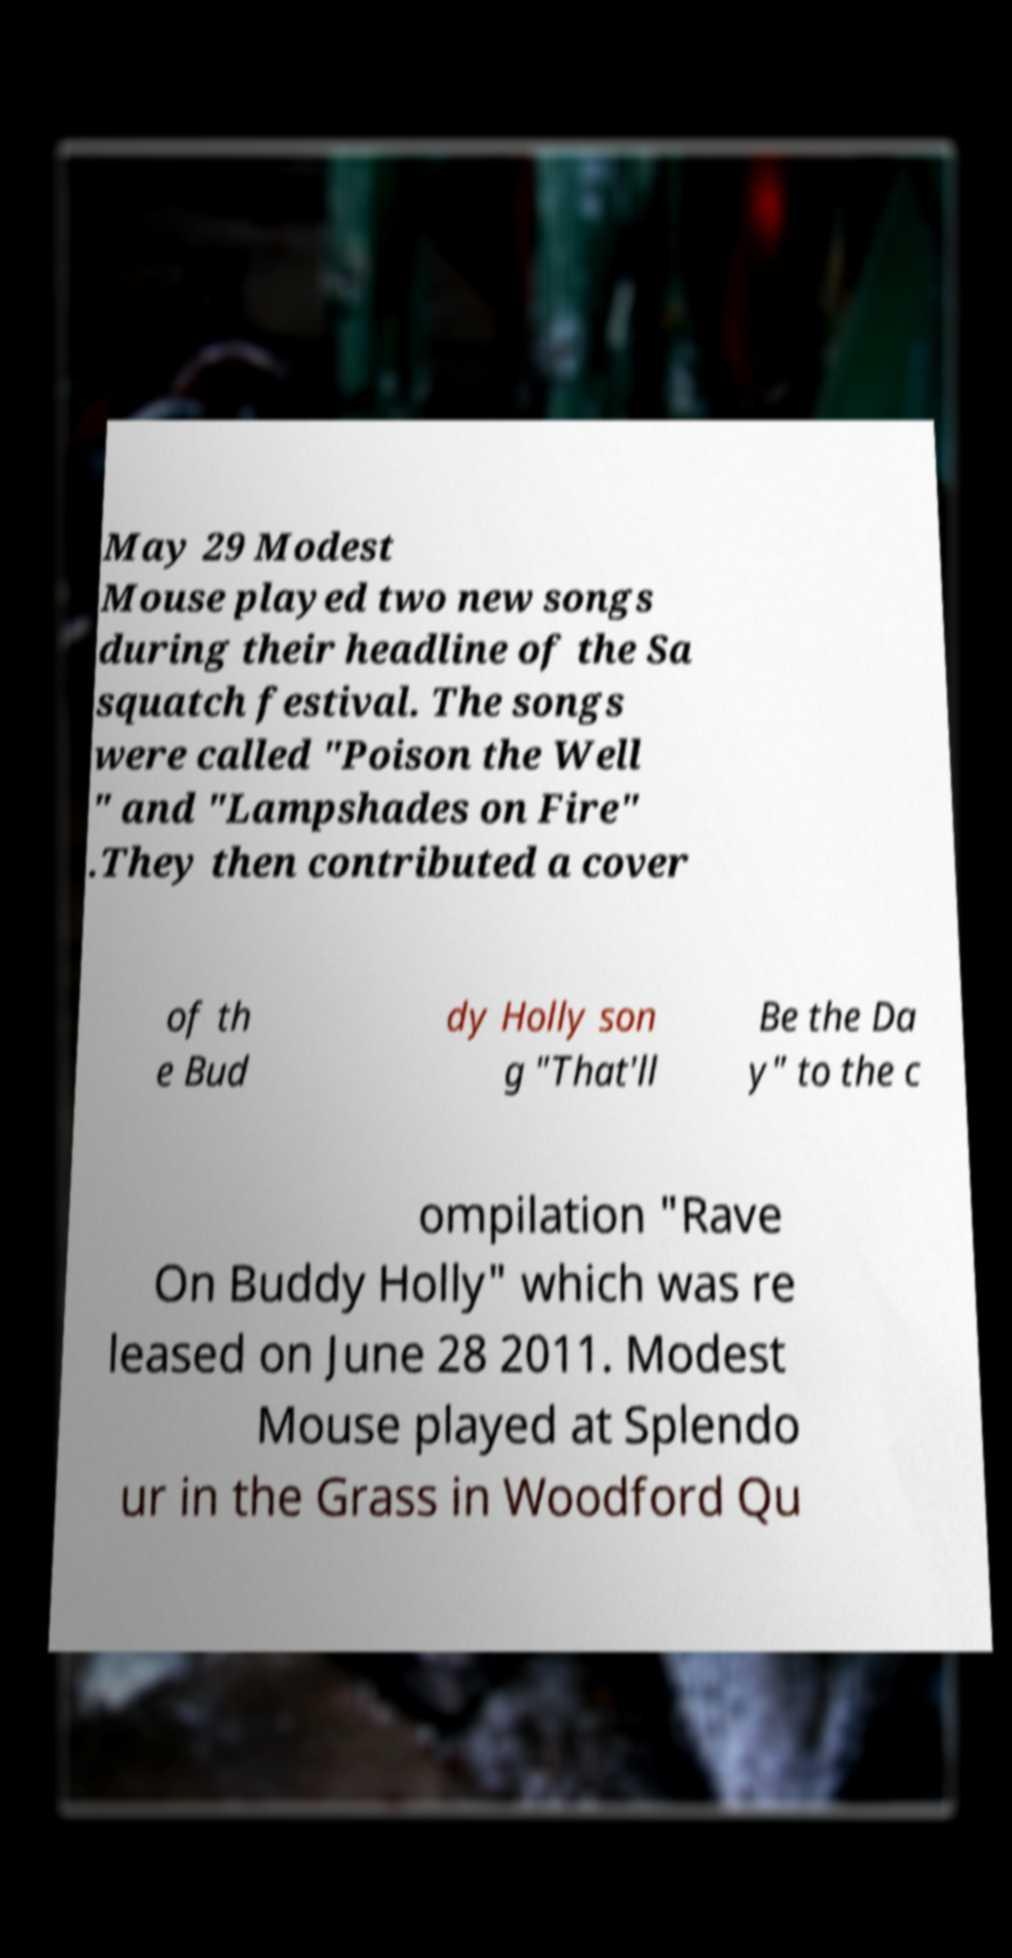Could you assist in decoding the text presented in this image and type it out clearly? May 29 Modest Mouse played two new songs during their headline of the Sa squatch festival. The songs were called "Poison the Well " and "Lampshades on Fire" .They then contributed a cover of th e Bud dy Holly son g "That'll Be the Da y" to the c ompilation "Rave On Buddy Holly" which was re leased on June 28 2011. Modest Mouse played at Splendo ur in the Grass in Woodford Qu 